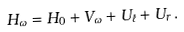<formula> <loc_0><loc_0><loc_500><loc_500>H _ { \omega } = H _ { 0 } + V _ { \omega } + U _ { \ell } + U _ { r } \, .</formula> 